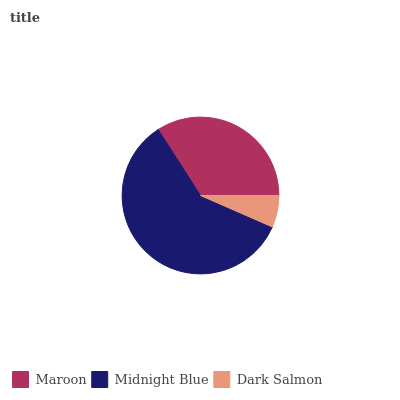Is Dark Salmon the minimum?
Answer yes or no. Yes. Is Midnight Blue the maximum?
Answer yes or no. Yes. Is Midnight Blue the minimum?
Answer yes or no. No. Is Dark Salmon the maximum?
Answer yes or no. No. Is Midnight Blue greater than Dark Salmon?
Answer yes or no. Yes. Is Dark Salmon less than Midnight Blue?
Answer yes or no. Yes. Is Dark Salmon greater than Midnight Blue?
Answer yes or no. No. Is Midnight Blue less than Dark Salmon?
Answer yes or no. No. Is Maroon the high median?
Answer yes or no. Yes. Is Maroon the low median?
Answer yes or no. Yes. Is Dark Salmon the high median?
Answer yes or no. No. Is Midnight Blue the low median?
Answer yes or no. No. 